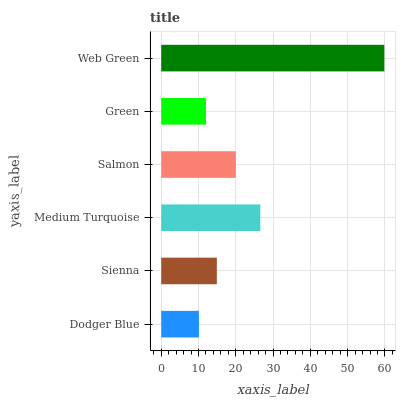Is Dodger Blue the minimum?
Answer yes or no. Yes. Is Web Green the maximum?
Answer yes or no. Yes. Is Sienna the minimum?
Answer yes or no. No. Is Sienna the maximum?
Answer yes or no. No. Is Sienna greater than Dodger Blue?
Answer yes or no. Yes. Is Dodger Blue less than Sienna?
Answer yes or no. Yes. Is Dodger Blue greater than Sienna?
Answer yes or no. No. Is Sienna less than Dodger Blue?
Answer yes or no. No. Is Salmon the high median?
Answer yes or no. Yes. Is Sienna the low median?
Answer yes or no. Yes. Is Medium Turquoise the high median?
Answer yes or no. No. Is Salmon the low median?
Answer yes or no. No. 